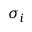Convert formula to latex. <formula><loc_0><loc_0><loc_500><loc_500>\sigma _ { i }</formula> 